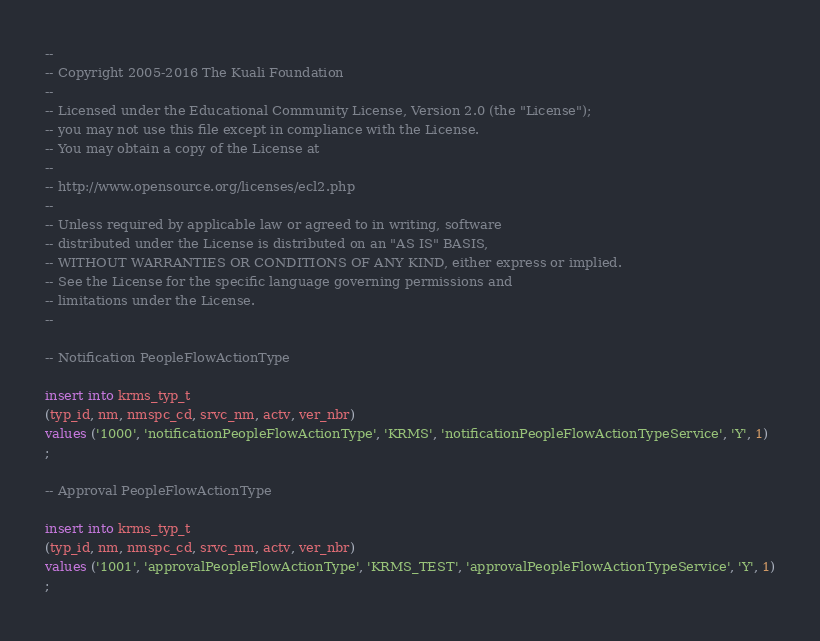Convert code to text. <code><loc_0><loc_0><loc_500><loc_500><_SQL_>--
-- Copyright 2005-2016 The Kuali Foundation
--
-- Licensed under the Educational Community License, Version 2.0 (the "License");
-- you may not use this file except in compliance with the License.
-- You may obtain a copy of the License at
--
-- http://www.opensource.org/licenses/ecl2.php
--
-- Unless required by applicable law or agreed to in writing, software
-- distributed under the License is distributed on an "AS IS" BASIS,
-- WITHOUT WARRANTIES OR CONDITIONS OF ANY KIND, either express or implied.
-- See the License for the specific language governing permissions and
-- limitations under the License.
--

-- Notification PeopleFlowActionType

insert into krms_typ_t
(typ_id, nm, nmspc_cd, srvc_nm, actv, ver_nbr)
values ('1000', 'notificationPeopleFlowActionType', 'KRMS', 'notificationPeopleFlowActionTypeService', 'Y', 1)
;

-- Approval PeopleFlowActionType

insert into krms_typ_t
(typ_id, nm, nmspc_cd, srvc_nm, actv, ver_nbr)
values ('1001', 'approvalPeopleFlowActionType', 'KRMS_TEST', 'approvalPeopleFlowActionTypeService', 'Y', 1)
;
</code> 